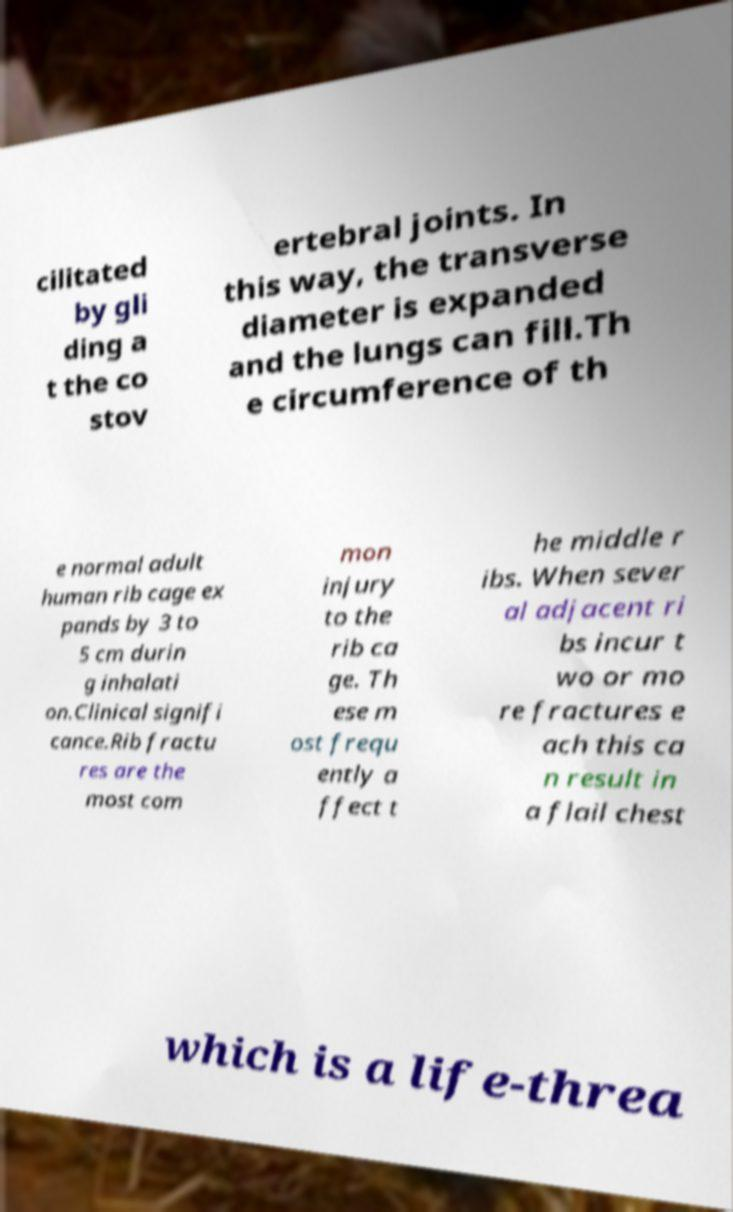Please read and relay the text visible in this image. What does it say? cilitated by gli ding a t the co stov ertebral joints. In this way, the transverse diameter is expanded and the lungs can fill.Th e circumference of th e normal adult human rib cage ex pands by 3 to 5 cm durin g inhalati on.Clinical signifi cance.Rib fractu res are the most com mon injury to the rib ca ge. Th ese m ost frequ ently a ffect t he middle r ibs. When sever al adjacent ri bs incur t wo or mo re fractures e ach this ca n result in a flail chest which is a life-threa 